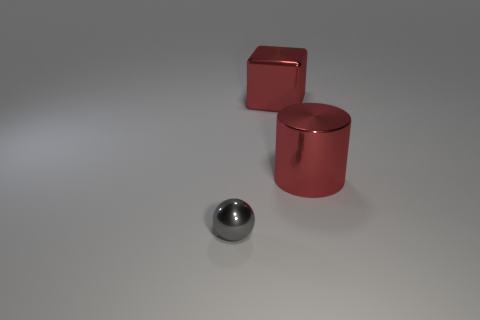What number of objects are either red objects in front of the block or big yellow metal spheres?
Give a very brief answer. 1. What number of tiny gray balls are to the right of the large cube behind the large red shiny cylinder?
Make the answer very short. 0. Is the number of cylinders in front of the big metal block greater than the number of small blue rubber cylinders?
Ensure brevity in your answer.  Yes. How big is the metallic object that is both behind the ball and on the left side of the large red metallic cylinder?
Your answer should be very brief. Large. What shape is the object that is on the left side of the big cylinder and in front of the large metal block?
Provide a succinct answer. Sphere. Is there a large shiny thing that is on the right side of the thing on the left side of the red shiny thing that is behind the red metallic cylinder?
Provide a short and direct response. Yes. How many things are either shiny things that are behind the small ball or metal objects that are to the right of the tiny metal ball?
Offer a terse response. 2. Are the big object to the right of the block and the gray object made of the same material?
Give a very brief answer. Yes. There is a thing that is both on the left side of the big cylinder and on the right side of the small gray ball; what material is it?
Your answer should be very brief. Metal. What is the color of the big shiny thing that is in front of the big red shiny object behind the large cylinder?
Your answer should be compact. Red. 